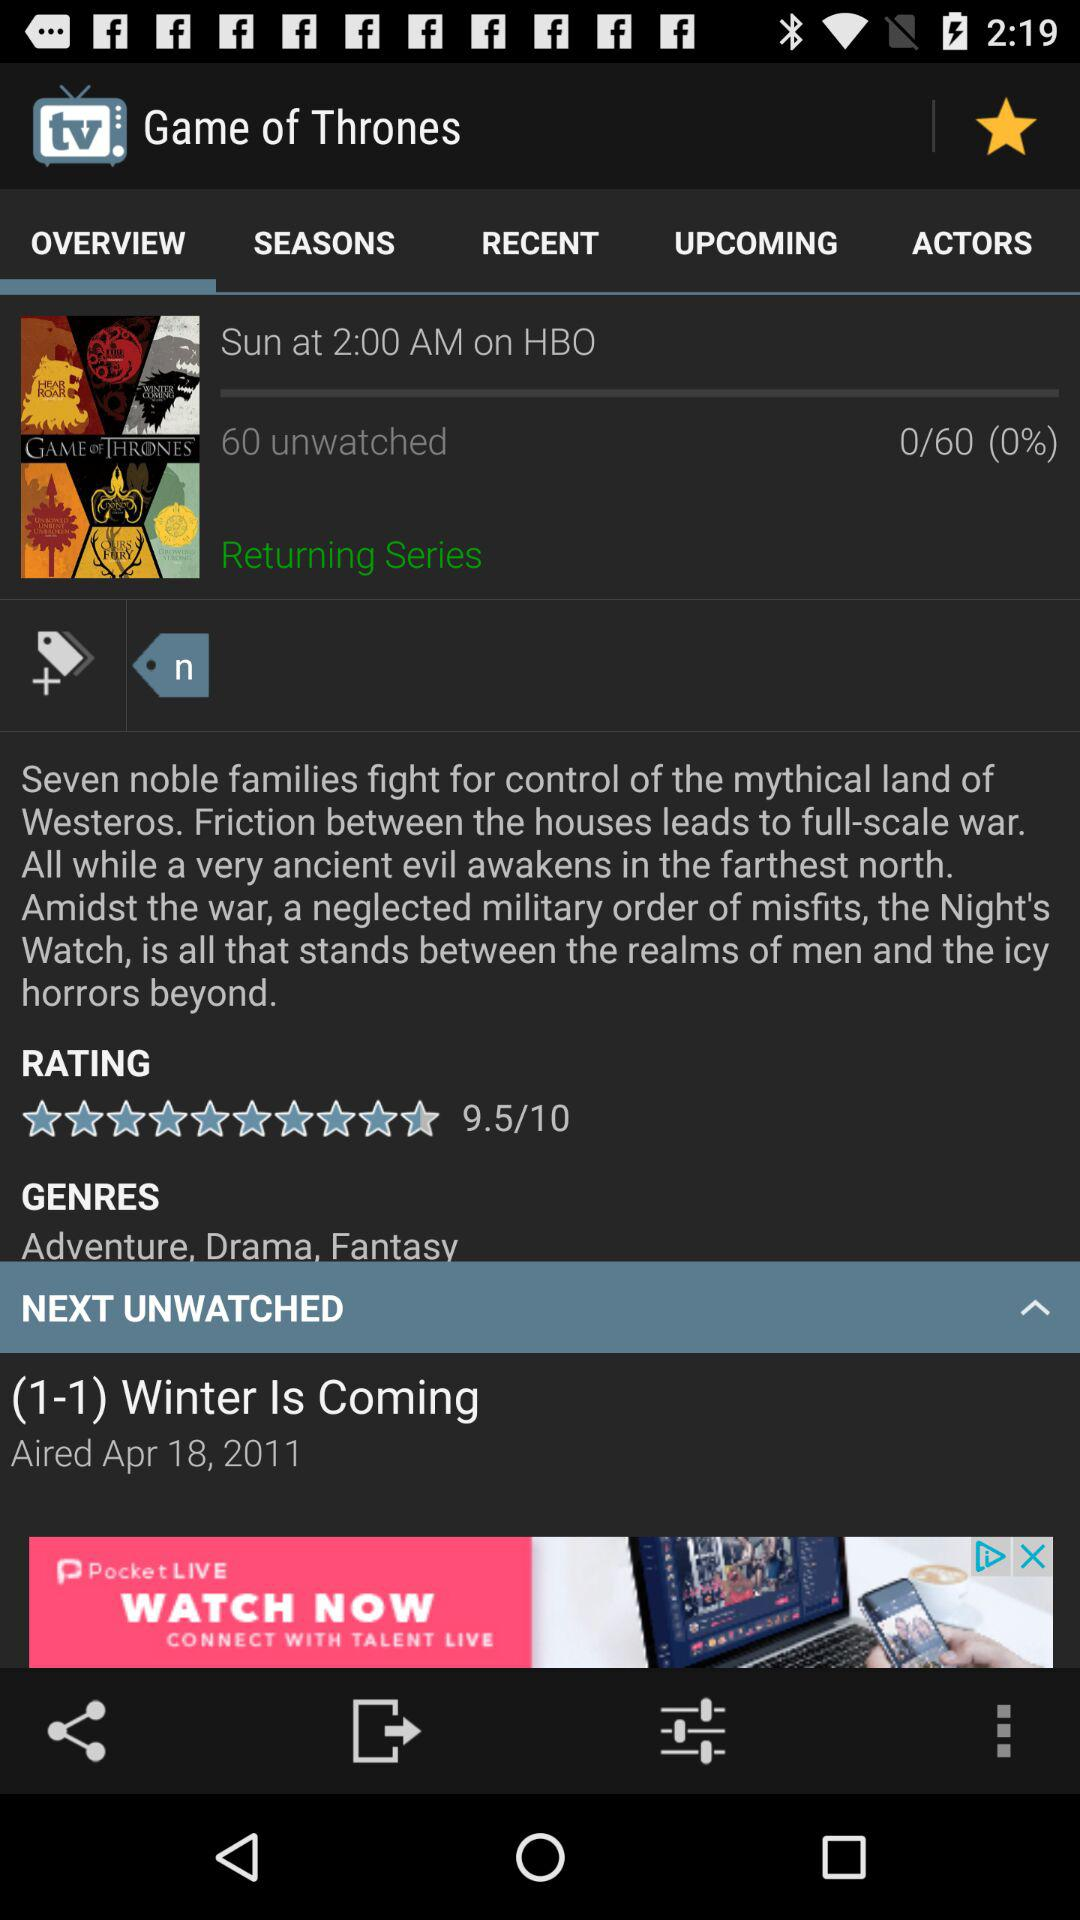What percent of people have not watched "Game of Thrones"? The percent of people that have not watched "Game of Thrones" is 0. 